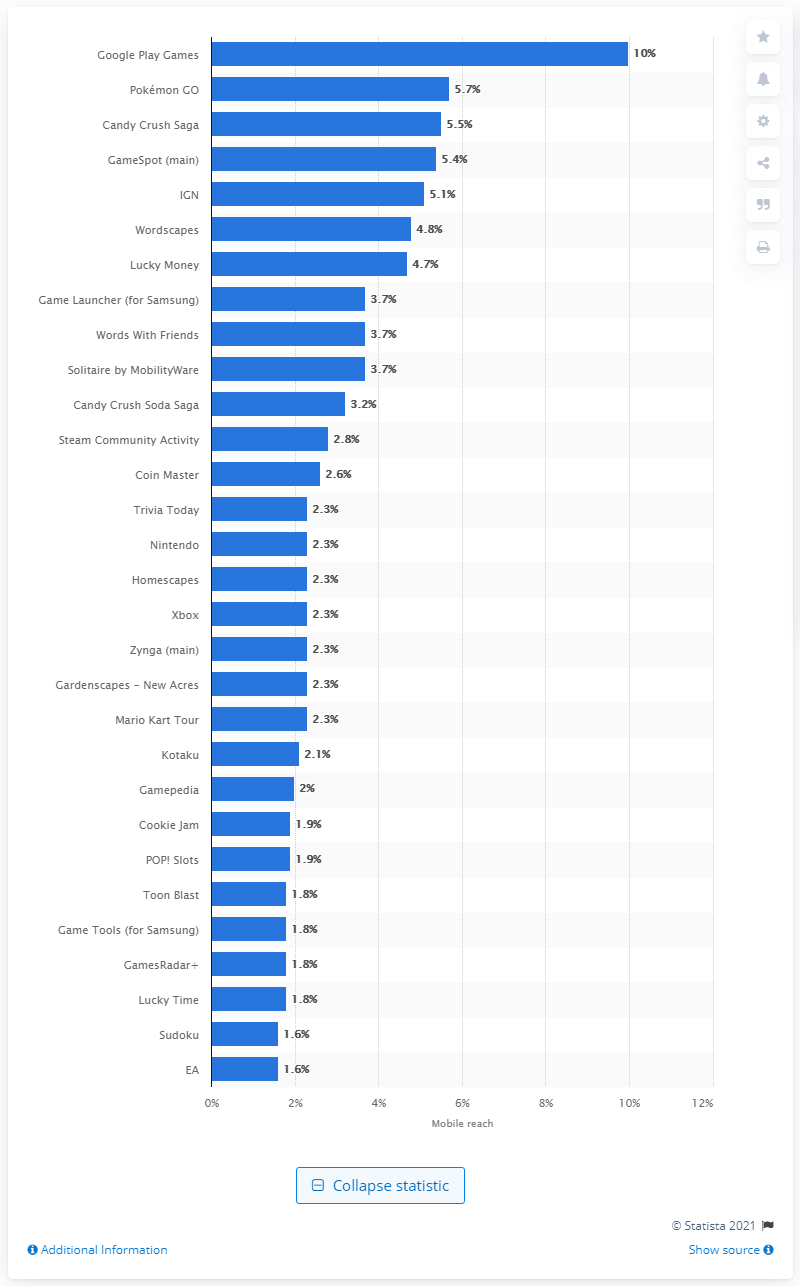Identify some key points in this picture. Candy Crush Saga had a mobile audience reach of 5.5 percent, making it a popular game among mobile users. In September 2019, approximately 3.7% of mobile users accessed Words With Friends. In September 2019, 3.7% of mobile users accessed the game "Words With Friends. 